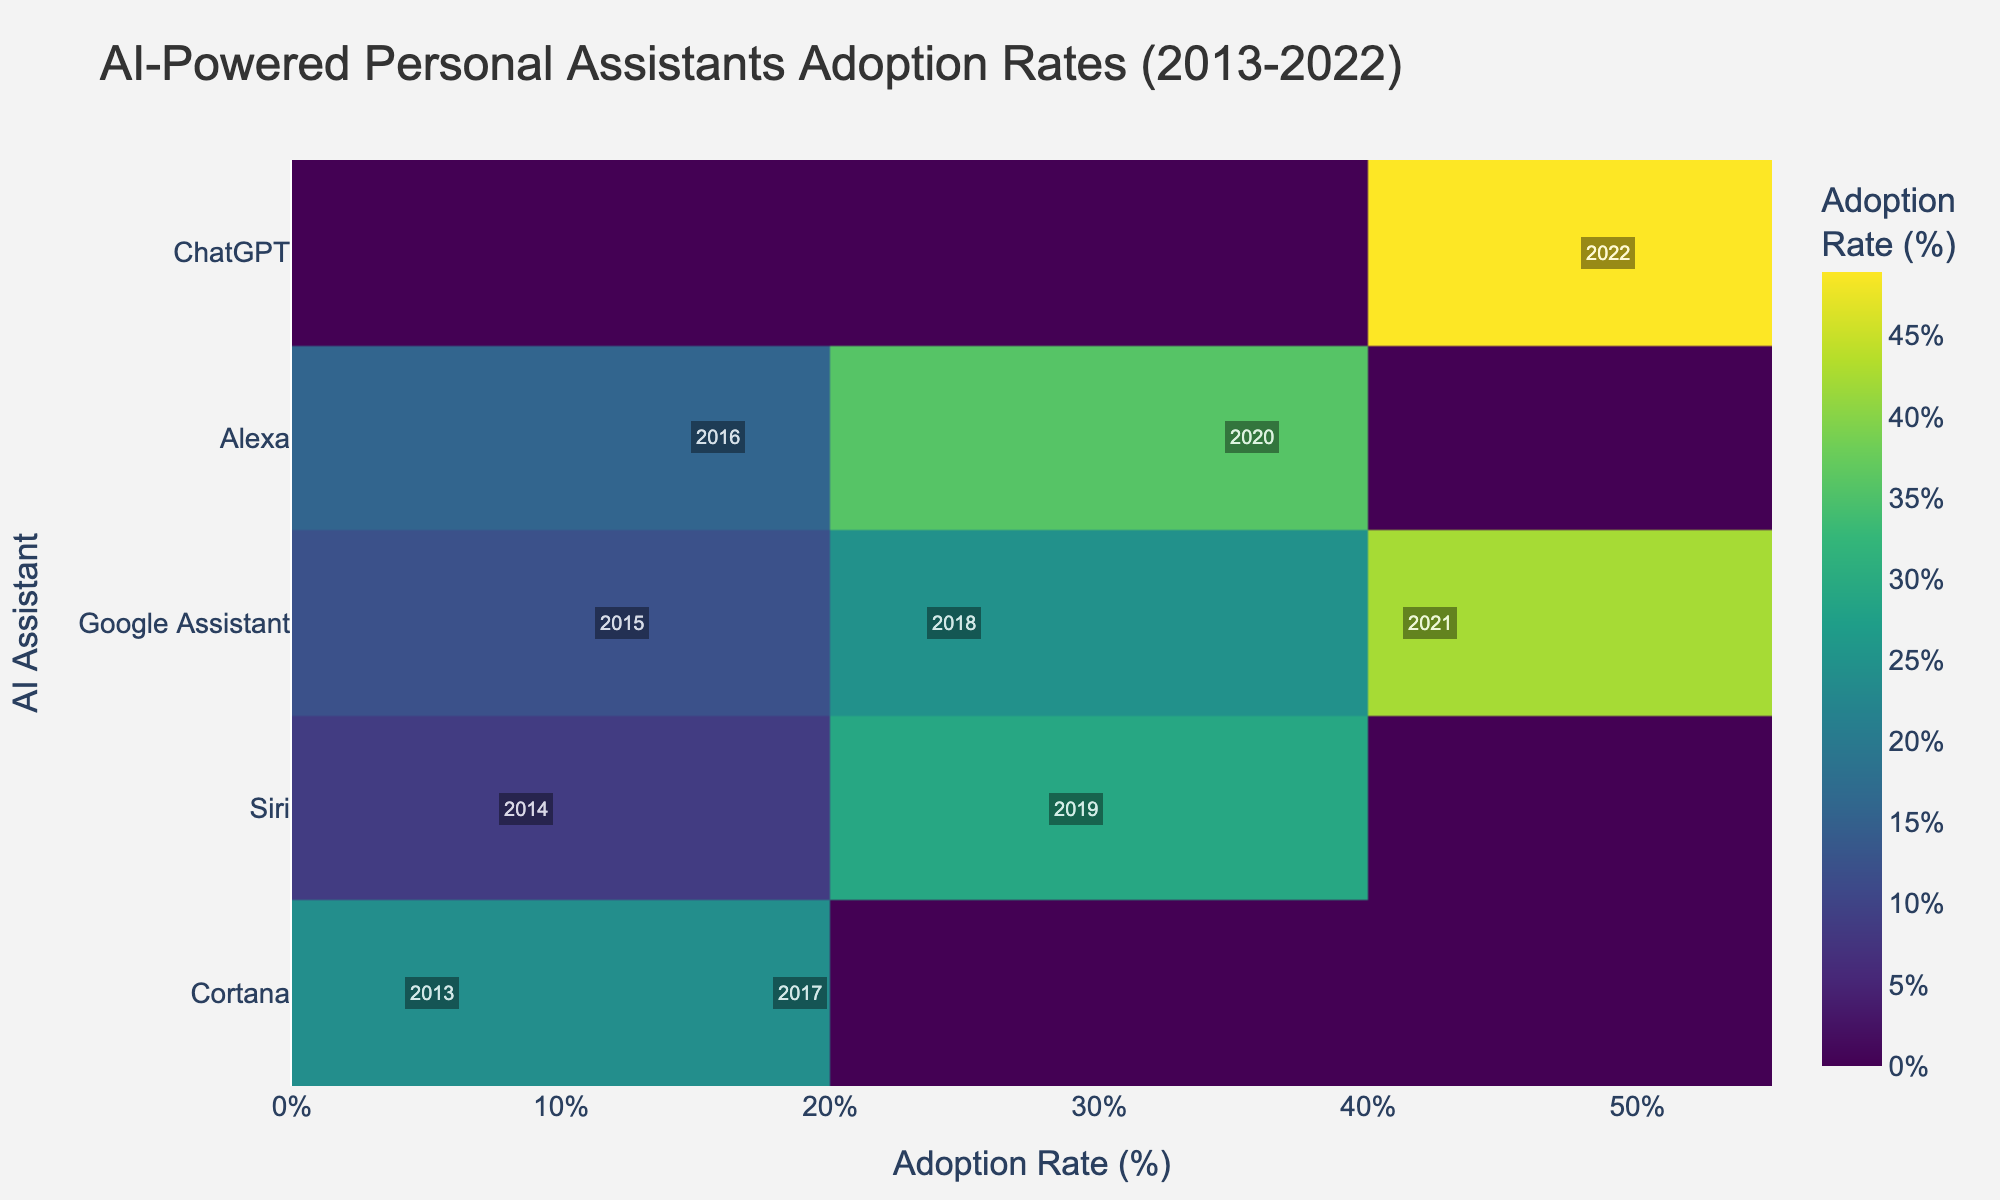What is the title of the plot? The title of the plot is provided at the top and usually formatted in a larger font.
Answer: AI-Powered Personal Assistants Adoption Rates (2013-2022) Which AI assistant had the highest adoption rate in 2022? Look at the labels on the y-axis and find the corresponding adoption rate on the x-axis. The assistant with the highest value will have the highest adoption rate.
Answer: ChatGPT How many assistants are displayed in the plot? Count the number of unique labels along the y-axis representing the AI assistants.
Answer: 5 Which year had the highest adoption rate for Google Assistant? Find the annotations along the x-axis for Google Assistant and identify the year with the highest adoption rate.
Answer: 2021 What was the adoption rate for Alexa in 2016? Navigate to the row for Alexa and locate the corresponding value on the x-axis for the year 2016 annotation.
Answer: 15.8% Did Cortana's adoption rate increase or decrease from 2013 to 2017? Compare the adoption rates of Cortana at the two points marked 2013 and 2017 and note the difference.
Answer: Increase Which assistant showed a consistent annual adoption rate increase from 2015 to 2021? Examine the adoption rates for each assistant over the specified years and identify the one with consistently increasing values.
Answer: Google Assistant What is the range of adoption rates for Siri displayed in the plot? Determine the minimum and maximum adoption rates for Siri and subtract the minimum from the maximum to find the range.
Answer: 8.7% - 29.1% Was the adoption rate for ChatGPT in 2022 higher than Alexa's in 2020? Compare the values on the x-axis for the annotations of ChatGPT in 2022 and Alexa in 2020.
Answer: Yes Which AI assistant had a starting adoption rate below 10%? Look at the earliest year annotations and their corresponding adoption rates; identify which one is below 10%.
Answer: Cortana 